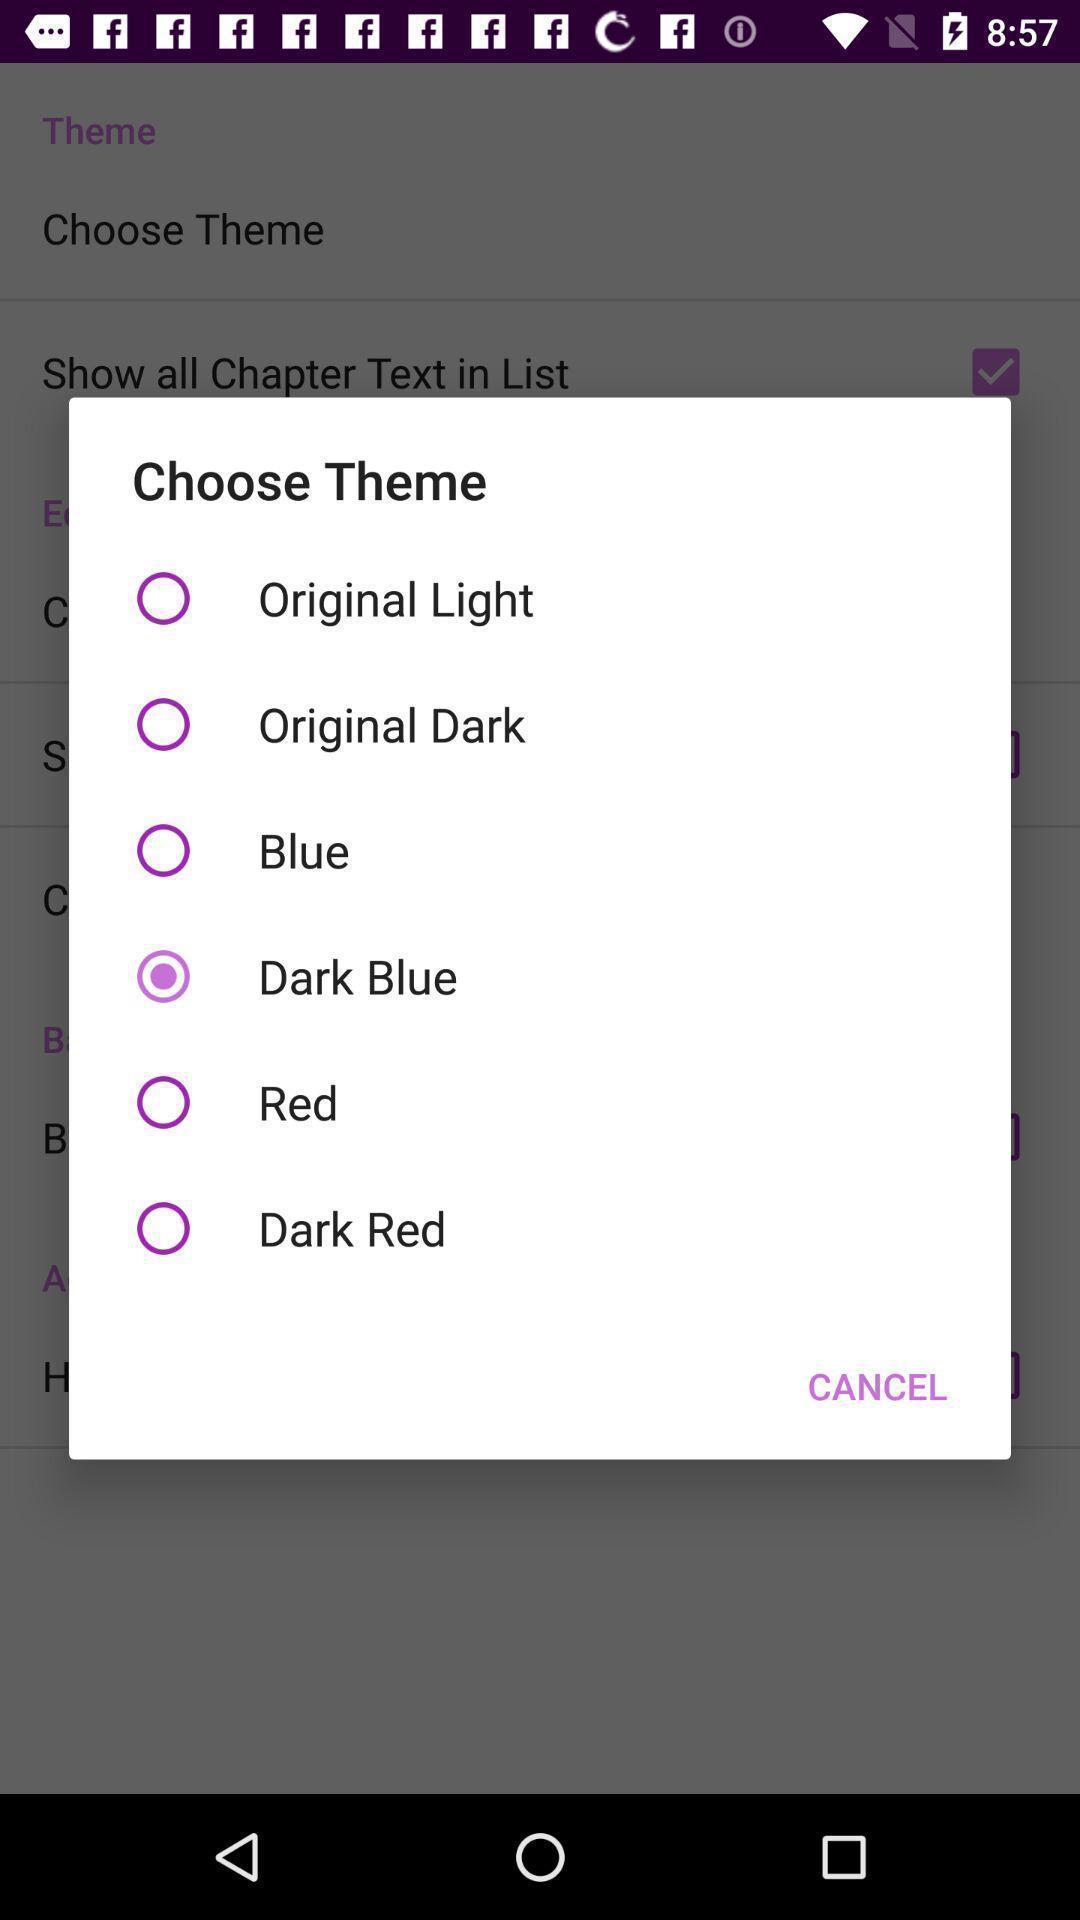Describe the visual elements of this screenshot. Pop-up showing options in a creative writing app. 